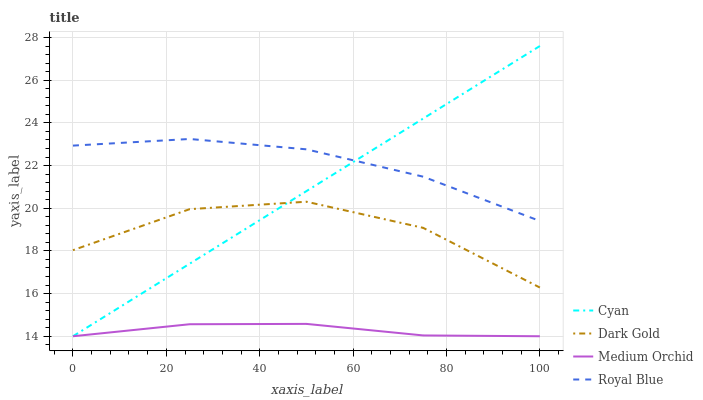Does Medium Orchid have the minimum area under the curve?
Answer yes or no. Yes. Does Royal Blue have the maximum area under the curve?
Answer yes or no. Yes. Does Royal Blue have the minimum area under the curve?
Answer yes or no. No. Does Medium Orchid have the maximum area under the curve?
Answer yes or no. No. Is Cyan the smoothest?
Answer yes or no. Yes. Is Dark Gold the roughest?
Answer yes or no. Yes. Is Medium Orchid the smoothest?
Answer yes or no. No. Is Medium Orchid the roughest?
Answer yes or no. No. Does Royal Blue have the lowest value?
Answer yes or no. No. Does Cyan have the highest value?
Answer yes or no. Yes. Does Royal Blue have the highest value?
Answer yes or no. No. Is Medium Orchid less than Dark Gold?
Answer yes or no. Yes. Is Royal Blue greater than Medium Orchid?
Answer yes or no. Yes. Does Cyan intersect Medium Orchid?
Answer yes or no. Yes. Is Cyan less than Medium Orchid?
Answer yes or no. No. Is Cyan greater than Medium Orchid?
Answer yes or no. No. Does Medium Orchid intersect Dark Gold?
Answer yes or no. No. 